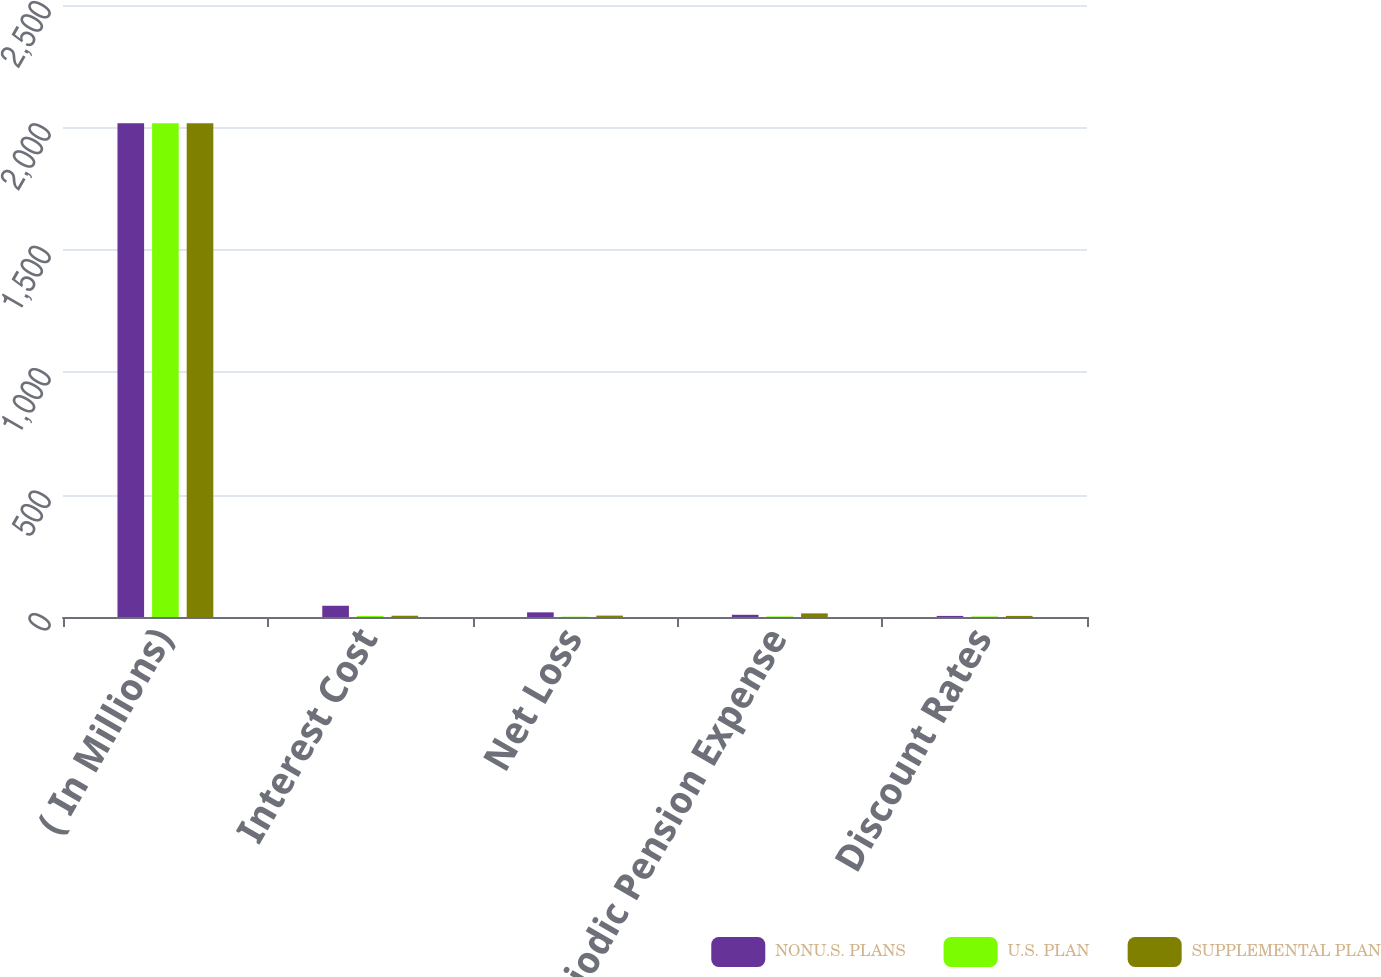Convert chart to OTSL. <chart><loc_0><loc_0><loc_500><loc_500><stacked_bar_chart><ecel><fcel>( In Millions)<fcel>Interest Cost<fcel>Net Loss<fcel>Net Periodic Pension Expense<fcel>Discount Rates<nl><fcel>NONU.S. PLANS<fcel>2017<fcel>45.9<fcel>19<fcel>9<fcel>4.46<nl><fcel>U.S. PLAN<fcel>2017<fcel>4<fcel>1.3<fcel>2.4<fcel>2.33<nl><fcel>SUPPLEMENTAL PLAN<fcel>2017<fcel>5.2<fcel>5.7<fcel>14.8<fcel>4.46<nl></chart> 